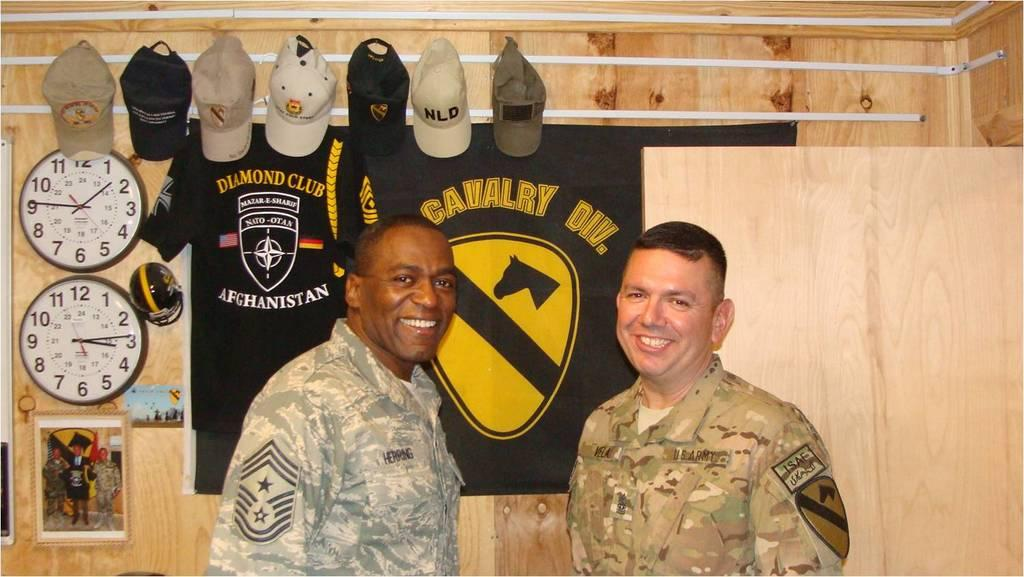<image>
Give a short and clear explanation of the subsequent image. Two smiling soldiers stand in front of a banner saying Calvary Division. 